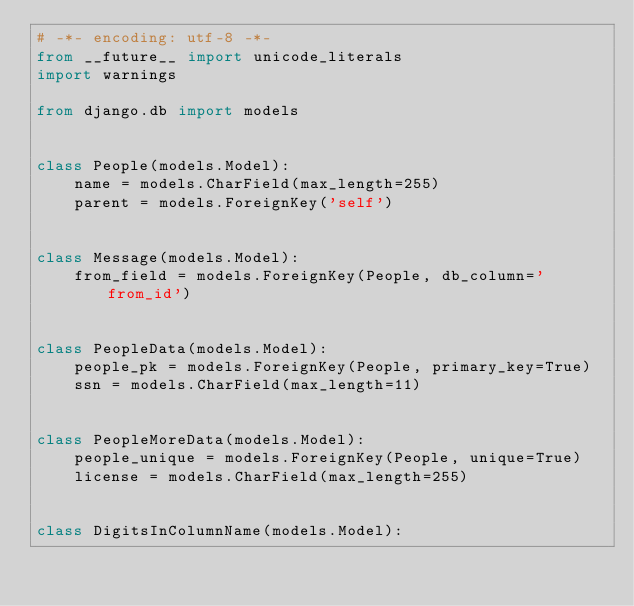<code> <loc_0><loc_0><loc_500><loc_500><_Python_># -*- encoding: utf-8 -*-
from __future__ import unicode_literals
import warnings

from django.db import models


class People(models.Model):
    name = models.CharField(max_length=255)
    parent = models.ForeignKey('self')


class Message(models.Model):
    from_field = models.ForeignKey(People, db_column='from_id')


class PeopleData(models.Model):
    people_pk = models.ForeignKey(People, primary_key=True)
    ssn = models.CharField(max_length=11)


class PeopleMoreData(models.Model):
    people_unique = models.ForeignKey(People, unique=True)
    license = models.CharField(max_length=255)


class DigitsInColumnName(models.Model):</code> 